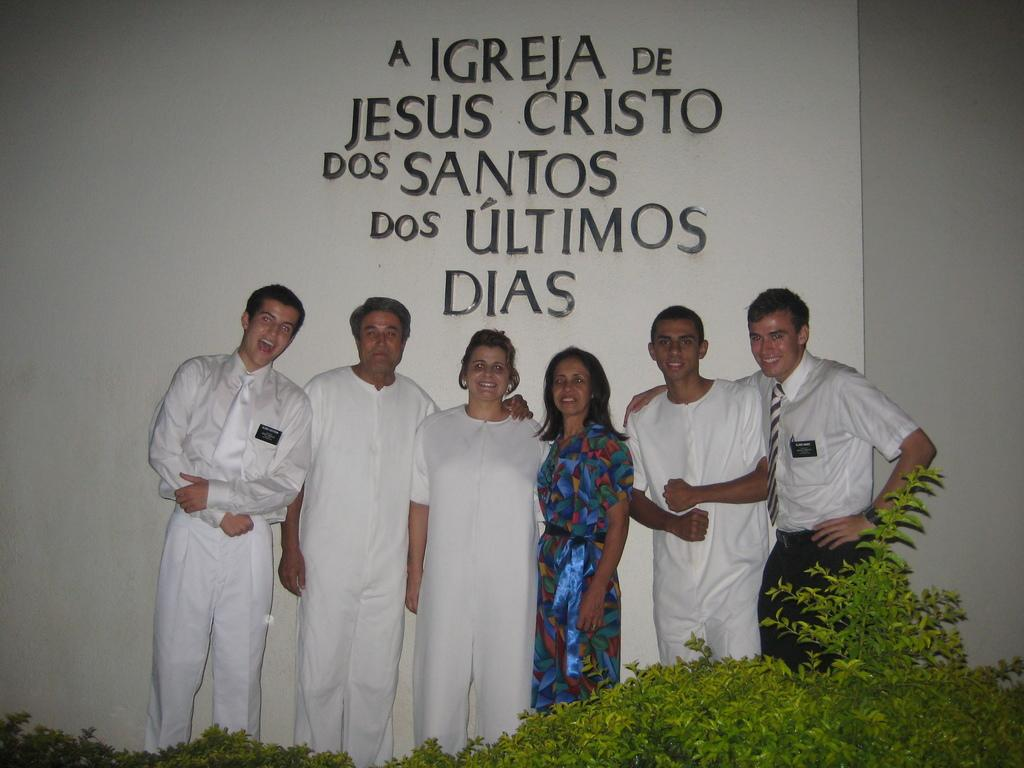How many people are in the image? There is a group of people in the image. What are the people doing in the image? The people are standing and smiling. What can be seen in the image besides the people? There are plants in the image. What is visible in the background of the image? There is text on a wall in the background of the image. What type of committee is meeting in the image? There is no committee meeting in the image; it features a group of people standing and smiling. What color is the balloon held by one of the people in the image? There is no balloon present in the image. 